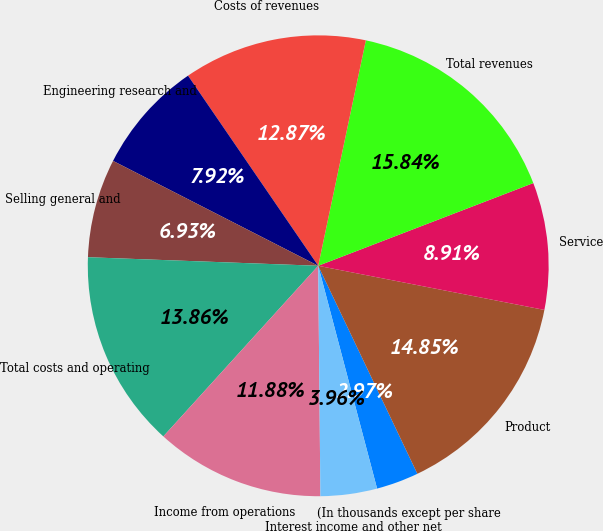Convert chart to OTSL. <chart><loc_0><loc_0><loc_500><loc_500><pie_chart><fcel>(In thousands except per share<fcel>Product<fcel>Service<fcel>Total revenues<fcel>Costs of revenues<fcel>Engineering research and<fcel>Selling general and<fcel>Total costs and operating<fcel>Income from operations<fcel>Interest income and other net<nl><fcel>2.97%<fcel>14.85%<fcel>8.91%<fcel>15.84%<fcel>12.87%<fcel>7.92%<fcel>6.93%<fcel>13.86%<fcel>11.88%<fcel>3.96%<nl></chart> 